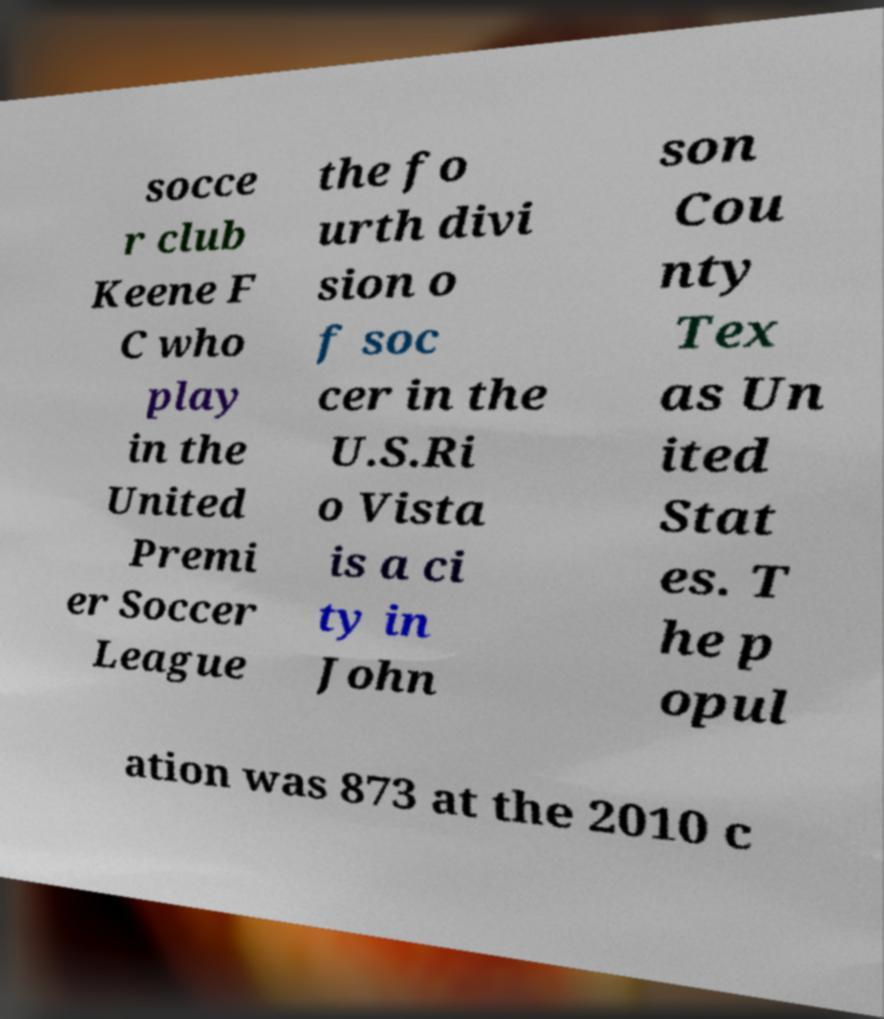I need the written content from this picture converted into text. Can you do that? socce r club Keene F C who play in the United Premi er Soccer League the fo urth divi sion o f soc cer in the U.S.Ri o Vista is a ci ty in John son Cou nty Tex as Un ited Stat es. T he p opul ation was 873 at the 2010 c 